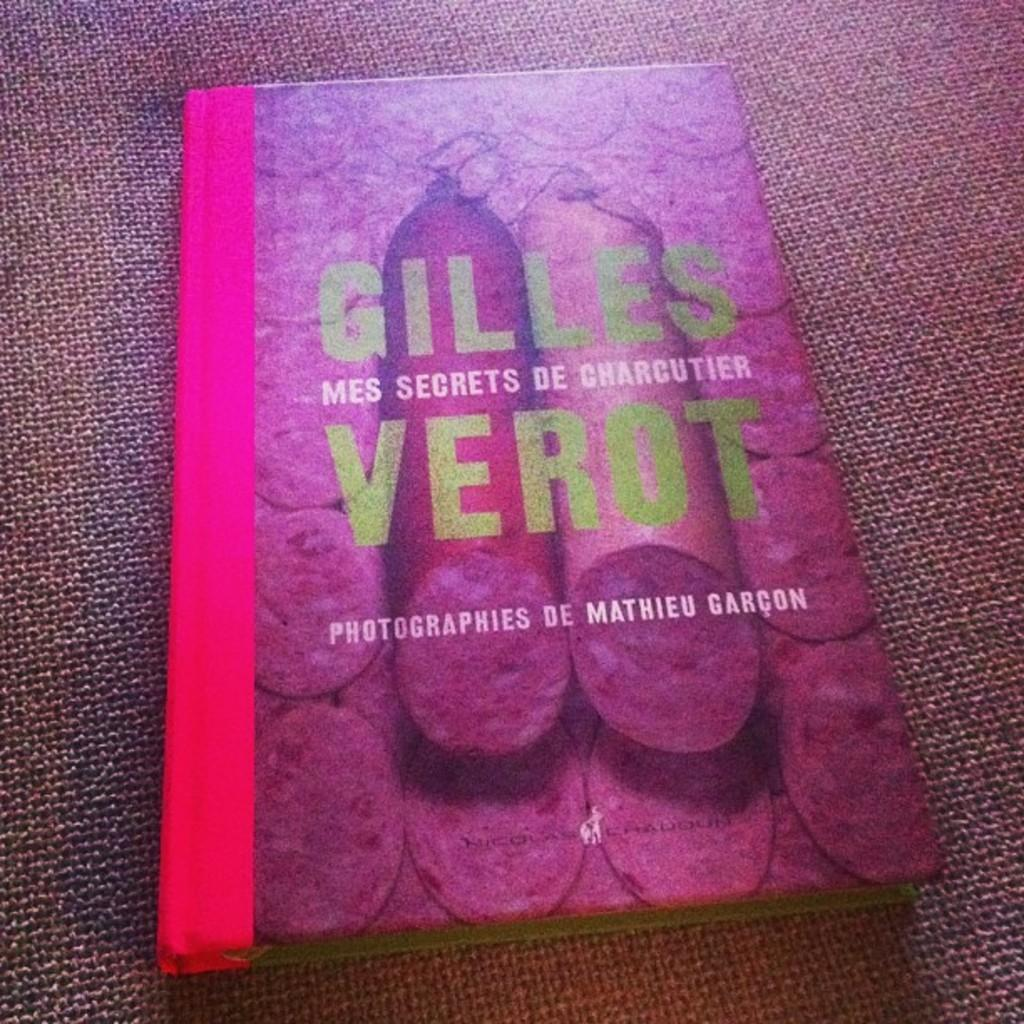<image>
Render a clear and concise summary of the photo. A red hardbound book has photographies de Mathieu Garcon. 